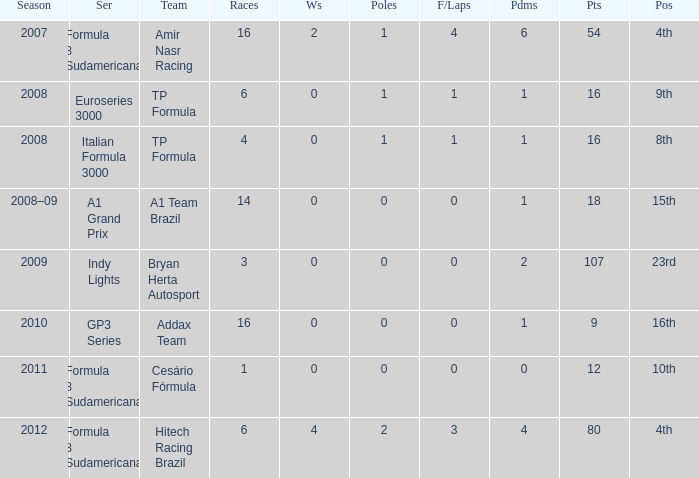How many points did he win in the race with more than 1.0 poles? 80.0. 